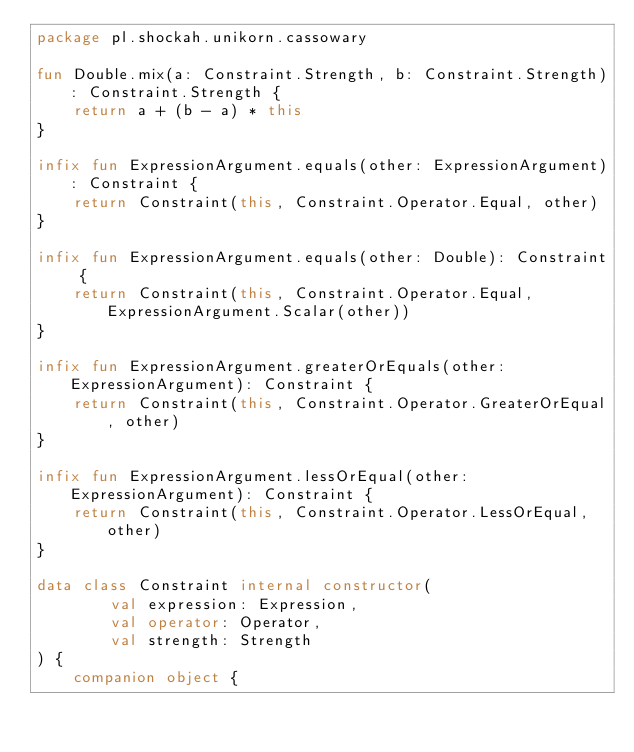<code> <loc_0><loc_0><loc_500><loc_500><_Kotlin_>package pl.shockah.unikorn.cassowary

fun Double.mix(a: Constraint.Strength, b: Constraint.Strength): Constraint.Strength {
	return a + (b - a) * this
}

infix fun ExpressionArgument.equals(other: ExpressionArgument): Constraint {
	return Constraint(this, Constraint.Operator.Equal, other)
}

infix fun ExpressionArgument.equals(other: Double): Constraint {
	return Constraint(this, Constraint.Operator.Equal, ExpressionArgument.Scalar(other))
}

infix fun ExpressionArgument.greaterOrEquals(other: ExpressionArgument): Constraint {
	return Constraint(this, Constraint.Operator.GreaterOrEqual, other)
}

infix fun ExpressionArgument.lessOrEqual(other: ExpressionArgument): Constraint {
	return Constraint(this, Constraint.Operator.LessOrEqual, other)
}

data class Constraint internal constructor(
		val expression: Expression,
		val operator: Operator,
		val strength: Strength
) {
	companion object {</code> 